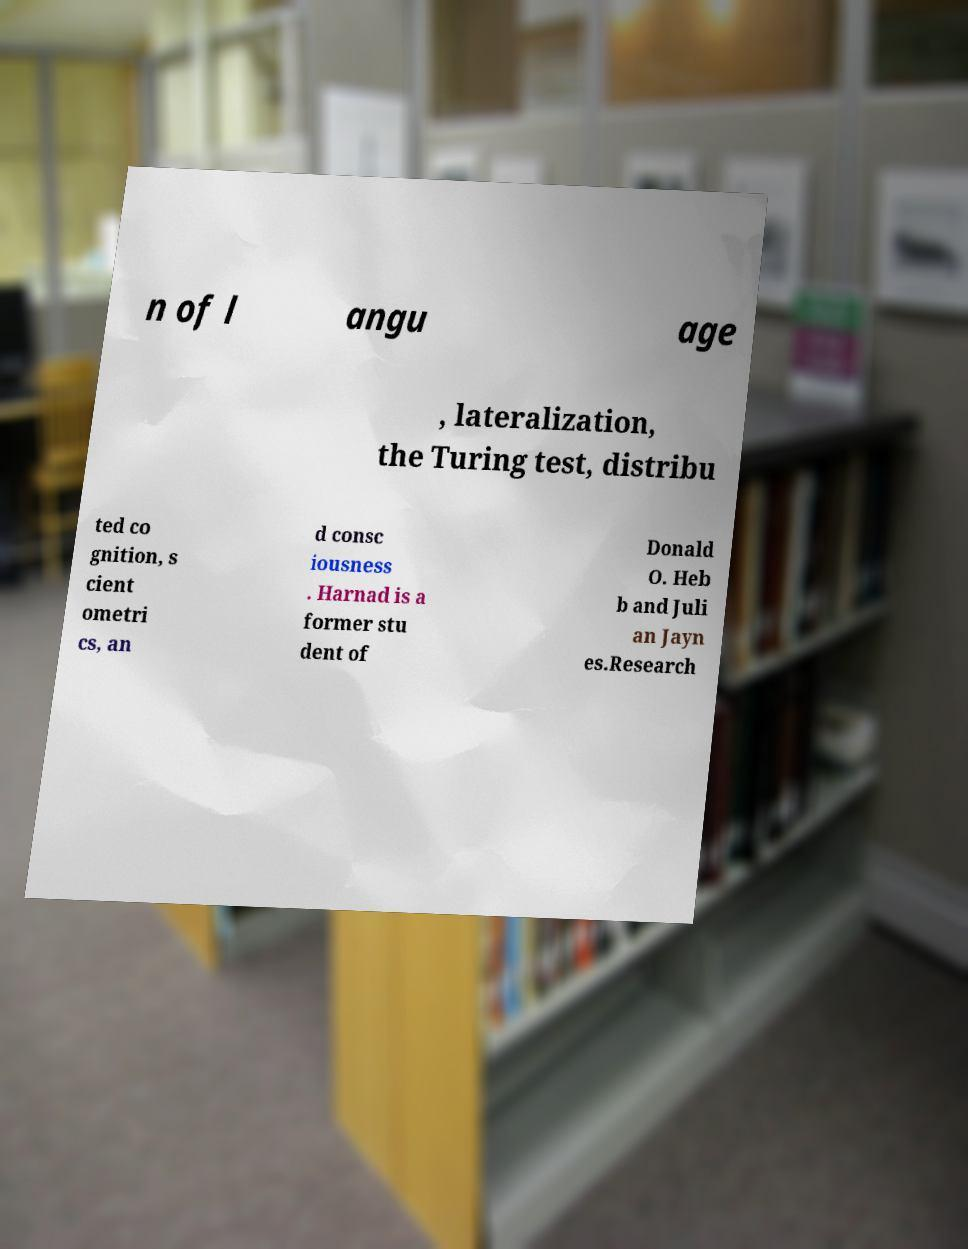For documentation purposes, I need the text within this image transcribed. Could you provide that? n of l angu age , lateralization, the Turing test, distribu ted co gnition, s cient ometri cs, an d consc iousness . Harnad is a former stu dent of Donald O. Heb b and Juli an Jayn es.Research 